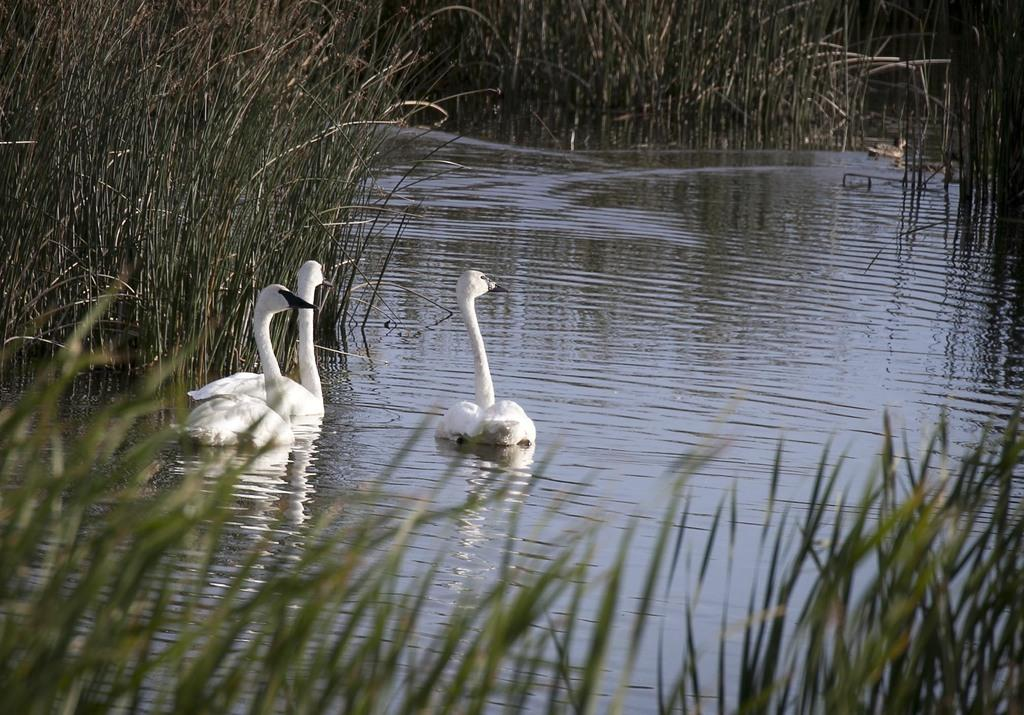How many swans are in the image? There are three swans in the image. What color are the swans? The swans are in white color. What is at the bottom of the image? There is grass at the bottom of the image. What is in the middle of the image? There is water in the middle of the image. What type of disease is affecting the swans in the image? There is no indication of any disease affecting the swans in the image; they appear to be healthy and in their natural environment. 